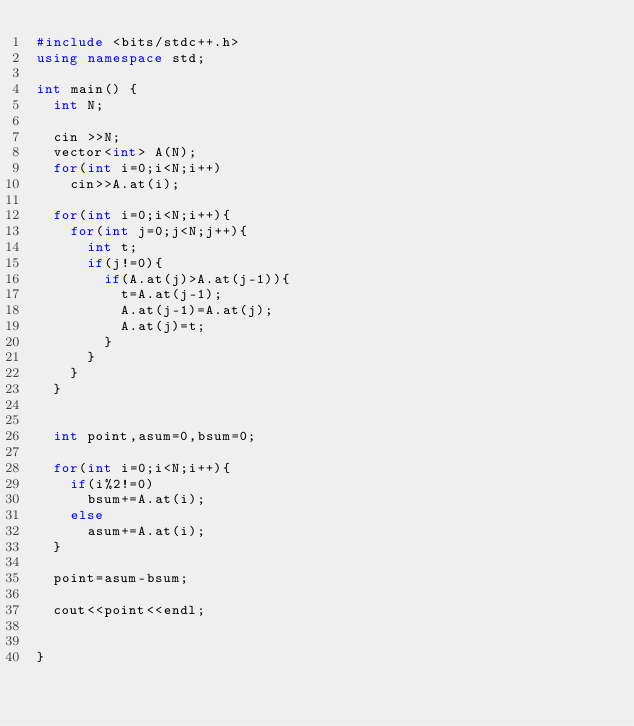Convert code to text. <code><loc_0><loc_0><loc_500><loc_500><_C++_>#include <bits/stdc++.h>
using namespace std;
 
int main() {
  int N;
  
  cin >>N;
  vector<int> A(N);
  for(int i=0;i<N;i++)
    cin>>A.at(i);
  
  for(int i=0;i<N;i++){
    for(int j=0;j<N;j++){
      int t;
      if(j!=0){
        if(A.at(j)>A.at(j-1)){
          t=A.at(j-1);
          A.at(j-1)=A.at(j);
          A.at(j)=t;
        }
      }
    }
  }
  
 
  int point,asum=0,bsum=0;
  
  for(int i=0;i<N;i++){
    if(i%2!=0)
      bsum+=A.at(i);
    else
      asum+=A.at(i);
  }
  
  point=asum-bsum;

  cout<<point<<endl;
 
 
}
        </code> 